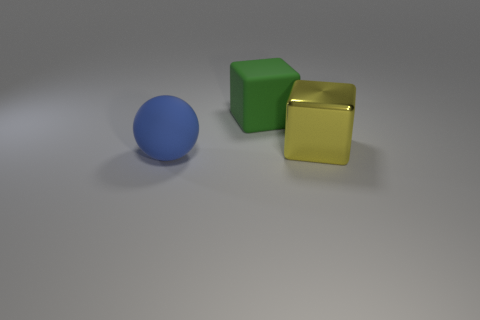What can you tell me about the surface these objects are resting on? The surface appears to be smooth and non-reflective, with a subtle gradient that suggests it's gently curving upwards. It has a neutral grey tone, providing a minimalistic background that doesn't distract from the objects. The absence of texture or additional elements on the surface draws our focus to the form and color of the objects. Does the surface tell us anything about the setting or context? The simplicity and neutrality of the surface hint that the setting might be a controlled environment, such as a photographic studio or a 3D rendering space, which is designed to emphasize the objects without any contextual information. This atmosphere is commonly used to keep the viewer's attention on the form and color of the subjects presented. 